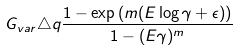<formula> <loc_0><loc_0><loc_500><loc_500>G _ { v a r } \triangle q \frac { 1 - \exp { \left ( m ( E \log \gamma + \epsilon ) \right ) } } { 1 - ( E \gamma ) ^ { m } }</formula> 